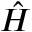Convert formula to latex. <formula><loc_0><loc_0><loc_500><loc_500>\hat { H }</formula> 